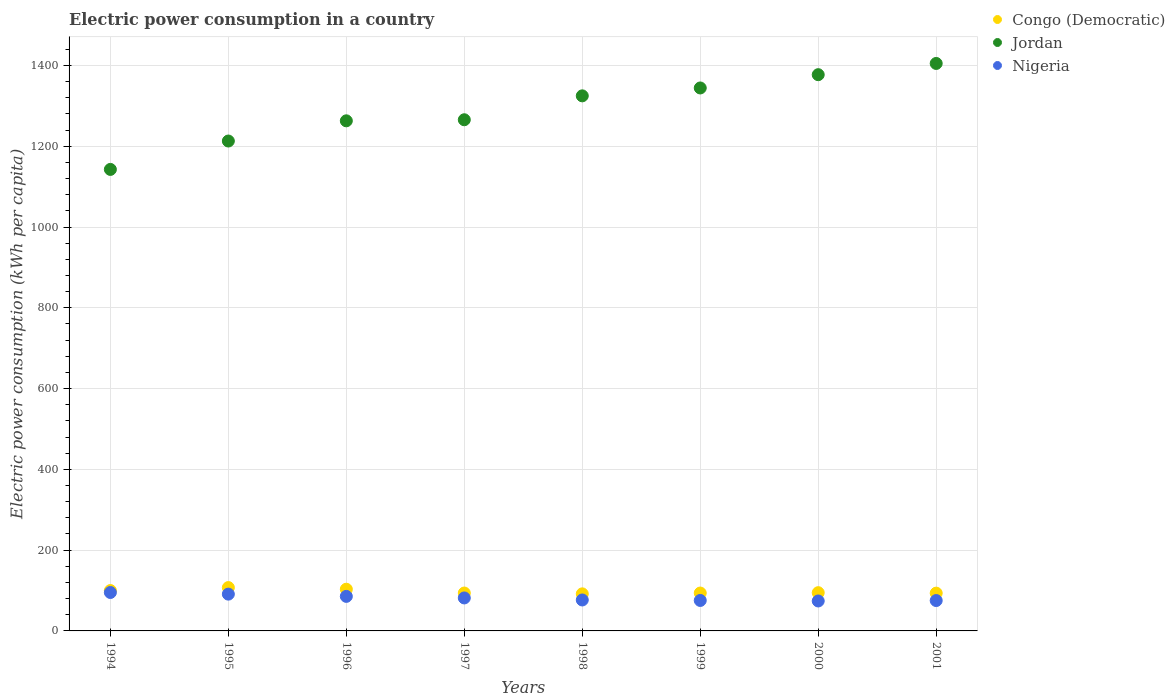How many different coloured dotlines are there?
Give a very brief answer. 3. Is the number of dotlines equal to the number of legend labels?
Provide a succinct answer. Yes. What is the electric power consumption in in Congo (Democratic) in 2001?
Your response must be concise. 93.57. Across all years, what is the maximum electric power consumption in in Nigeria?
Your answer should be very brief. 95.15. Across all years, what is the minimum electric power consumption in in Congo (Democratic)?
Your answer should be compact. 91.77. What is the total electric power consumption in in Nigeria in the graph?
Offer a terse response. 654.74. What is the difference between the electric power consumption in in Congo (Democratic) in 1997 and that in 1998?
Provide a short and direct response. 2.06. What is the difference between the electric power consumption in in Congo (Democratic) in 1998 and the electric power consumption in in Jordan in 2000?
Offer a terse response. -1285.34. What is the average electric power consumption in in Congo (Democratic) per year?
Provide a succinct answer. 97.27. In the year 1995, what is the difference between the electric power consumption in in Jordan and electric power consumption in in Nigeria?
Keep it short and to the point. 1121.79. In how many years, is the electric power consumption in in Congo (Democratic) greater than 200 kWh per capita?
Your response must be concise. 0. What is the ratio of the electric power consumption in in Congo (Democratic) in 1996 to that in 2001?
Offer a very short reply. 1.1. Is the electric power consumption in in Jordan in 1996 less than that in 1999?
Provide a short and direct response. Yes. Is the difference between the electric power consumption in in Jordan in 1997 and 1999 greater than the difference between the electric power consumption in in Nigeria in 1997 and 1999?
Your answer should be very brief. No. What is the difference between the highest and the second highest electric power consumption in in Jordan?
Provide a short and direct response. 27.81. What is the difference between the highest and the lowest electric power consumption in in Nigeria?
Give a very brief answer. 21.01. Is it the case that in every year, the sum of the electric power consumption in in Nigeria and electric power consumption in in Congo (Democratic)  is greater than the electric power consumption in in Jordan?
Make the answer very short. No. Does the electric power consumption in in Nigeria monotonically increase over the years?
Provide a short and direct response. No. Is the electric power consumption in in Jordan strictly greater than the electric power consumption in in Congo (Democratic) over the years?
Your response must be concise. Yes. Is the electric power consumption in in Congo (Democratic) strictly less than the electric power consumption in in Nigeria over the years?
Offer a terse response. No. How many years are there in the graph?
Your response must be concise. 8. Does the graph contain any zero values?
Offer a terse response. No. Where does the legend appear in the graph?
Provide a short and direct response. Top right. What is the title of the graph?
Make the answer very short. Electric power consumption in a country. Does "Myanmar" appear as one of the legend labels in the graph?
Offer a terse response. No. What is the label or title of the Y-axis?
Your response must be concise. Electric power consumption (kWh per capita). What is the Electric power consumption (kWh per capita) in Congo (Democratic) in 1994?
Offer a terse response. 99.94. What is the Electric power consumption (kWh per capita) in Jordan in 1994?
Provide a short and direct response. 1142.58. What is the Electric power consumption (kWh per capita) of Nigeria in 1994?
Offer a very short reply. 95.15. What is the Electric power consumption (kWh per capita) of Congo (Democratic) in 1995?
Give a very brief answer. 107.32. What is the Electric power consumption (kWh per capita) in Jordan in 1995?
Offer a terse response. 1212.87. What is the Electric power consumption (kWh per capita) of Nigeria in 1995?
Your response must be concise. 91.09. What is the Electric power consumption (kWh per capita) of Congo (Democratic) in 1996?
Offer a very short reply. 103.24. What is the Electric power consumption (kWh per capita) of Jordan in 1996?
Offer a terse response. 1262.89. What is the Electric power consumption (kWh per capita) of Nigeria in 1996?
Your response must be concise. 85.52. What is the Electric power consumption (kWh per capita) in Congo (Democratic) in 1997?
Provide a short and direct response. 93.83. What is the Electric power consumption (kWh per capita) in Jordan in 1997?
Provide a short and direct response. 1265.53. What is the Electric power consumption (kWh per capita) in Nigeria in 1997?
Keep it short and to the point. 81.63. What is the Electric power consumption (kWh per capita) of Congo (Democratic) in 1998?
Make the answer very short. 91.77. What is the Electric power consumption (kWh per capita) in Jordan in 1998?
Offer a very short reply. 1324.72. What is the Electric power consumption (kWh per capita) in Nigeria in 1998?
Offer a terse response. 76.61. What is the Electric power consumption (kWh per capita) of Congo (Democratic) in 1999?
Your answer should be compact. 93.78. What is the Electric power consumption (kWh per capita) in Jordan in 1999?
Provide a short and direct response. 1344.23. What is the Electric power consumption (kWh per capita) of Nigeria in 1999?
Offer a terse response. 75.41. What is the Electric power consumption (kWh per capita) in Congo (Democratic) in 2000?
Your answer should be very brief. 94.67. What is the Electric power consumption (kWh per capita) of Jordan in 2000?
Give a very brief answer. 1377.11. What is the Electric power consumption (kWh per capita) in Nigeria in 2000?
Offer a very short reply. 74.13. What is the Electric power consumption (kWh per capita) in Congo (Democratic) in 2001?
Ensure brevity in your answer.  93.57. What is the Electric power consumption (kWh per capita) of Jordan in 2001?
Keep it short and to the point. 1404.92. What is the Electric power consumption (kWh per capita) in Nigeria in 2001?
Give a very brief answer. 75.2. Across all years, what is the maximum Electric power consumption (kWh per capita) of Congo (Democratic)?
Ensure brevity in your answer.  107.32. Across all years, what is the maximum Electric power consumption (kWh per capita) in Jordan?
Give a very brief answer. 1404.92. Across all years, what is the maximum Electric power consumption (kWh per capita) of Nigeria?
Offer a terse response. 95.15. Across all years, what is the minimum Electric power consumption (kWh per capita) in Congo (Democratic)?
Provide a short and direct response. 91.77. Across all years, what is the minimum Electric power consumption (kWh per capita) of Jordan?
Your answer should be very brief. 1142.58. Across all years, what is the minimum Electric power consumption (kWh per capita) of Nigeria?
Keep it short and to the point. 74.13. What is the total Electric power consumption (kWh per capita) in Congo (Democratic) in the graph?
Offer a terse response. 778.12. What is the total Electric power consumption (kWh per capita) of Jordan in the graph?
Keep it short and to the point. 1.03e+04. What is the total Electric power consumption (kWh per capita) in Nigeria in the graph?
Your answer should be very brief. 654.74. What is the difference between the Electric power consumption (kWh per capita) of Congo (Democratic) in 1994 and that in 1995?
Give a very brief answer. -7.38. What is the difference between the Electric power consumption (kWh per capita) in Jordan in 1994 and that in 1995?
Keep it short and to the point. -70.3. What is the difference between the Electric power consumption (kWh per capita) of Nigeria in 1994 and that in 1995?
Your answer should be compact. 4.06. What is the difference between the Electric power consumption (kWh per capita) of Congo (Democratic) in 1994 and that in 1996?
Ensure brevity in your answer.  -3.29. What is the difference between the Electric power consumption (kWh per capita) in Jordan in 1994 and that in 1996?
Give a very brief answer. -120.31. What is the difference between the Electric power consumption (kWh per capita) of Nigeria in 1994 and that in 1996?
Give a very brief answer. 9.62. What is the difference between the Electric power consumption (kWh per capita) in Congo (Democratic) in 1994 and that in 1997?
Give a very brief answer. 6.11. What is the difference between the Electric power consumption (kWh per capita) of Jordan in 1994 and that in 1997?
Give a very brief answer. -122.95. What is the difference between the Electric power consumption (kWh per capita) of Nigeria in 1994 and that in 1997?
Ensure brevity in your answer.  13.51. What is the difference between the Electric power consumption (kWh per capita) of Congo (Democratic) in 1994 and that in 1998?
Make the answer very short. 8.17. What is the difference between the Electric power consumption (kWh per capita) of Jordan in 1994 and that in 1998?
Your answer should be compact. -182.14. What is the difference between the Electric power consumption (kWh per capita) of Nigeria in 1994 and that in 1998?
Provide a short and direct response. 18.53. What is the difference between the Electric power consumption (kWh per capita) of Congo (Democratic) in 1994 and that in 1999?
Give a very brief answer. 6.16. What is the difference between the Electric power consumption (kWh per capita) of Jordan in 1994 and that in 1999?
Your answer should be very brief. -201.66. What is the difference between the Electric power consumption (kWh per capita) in Nigeria in 1994 and that in 1999?
Your answer should be compact. 19.74. What is the difference between the Electric power consumption (kWh per capita) in Congo (Democratic) in 1994 and that in 2000?
Your answer should be compact. 5.27. What is the difference between the Electric power consumption (kWh per capita) in Jordan in 1994 and that in 2000?
Provide a succinct answer. -234.53. What is the difference between the Electric power consumption (kWh per capita) in Nigeria in 1994 and that in 2000?
Make the answer very short. 21.01. What is the difference between the Electric power consumption (kWh per capita) in Congo (Democratic) in 1994 and that in 2001?
Your answer should be very brief. 6.37. What is the difference between the Electric power consumption (kWh per capita) in Jordan in 1994 and that in 2001?
Provide a succinct answer. -262.35. What is the difference between the Electric power consumption (kWh per capita) in Nigeria in 1994 and that in 2001?
Provide a short and direct response. 19.95. What is the difference between the Electric power consumption (kWh per capita) of Congo (Democratic) in 1995 and that in 1996?
Ensure brevity in your answer.  4.08. What is the difference between the Electric power consumption (kWh per capita) in Jordan in 1995 and that in 1996?
Offer a very short reply. -50.02. What is the difference between the Electric power consumption (kWh per capita) in Nigeria in 1995 and that in 1996?
Offer a very short reply. 5.56. What is the difference between the Electric power consumption (kWh per capita) in Congo (Democratic) in 1995 and that in 1997?
Provide a succinct answer. 13.48. What is the difference between the Electric power consumption (kWh per capita) in Jordan in 1995 and that in 1997?
Offer a very short reply. -52.65. What is the difference between the Electric power consumption (kWh per capita) in Nigeria in 1995 and that in 1997?
Make the answer very short. 9.45. What is the difference between the Electric power consumption (kWh per capita) of Congo (Democratic) in 1995 and that in 1998?
Keep it short and to the point. 15.55. What is the difference between the Electric power consumption (kWh per capita) of Jordan in 1995 and that in 1998?
Your answer should be very brief. -111.84. What is the difference between the Electric power consumption (kWh per capita) of Nigeria in 1995 and that in 1998?
Provide a short and direct response. 14.47. What is the difference between the Electric power consumption (kWh per capita) of Congo (Democratic) in 1995 and that in 1999?
Provide a short and direct response. 13.53. What is the difference between the Electric power consumption (kWh per capita) in Jordan in 1995 and that in 1999?
Ensure brevity in your answer.  -131.36. What is the difference between the Electric power consumption (kWh per capita) in Nigeria in 1995 and that in 1999?
Keep it short and to the point. 15.68. What is the difference between the Electric power consumption (kWh per capita) in Congo (Democratic) in 1995 and that in 2000?
Make the answer very short. 12.64. What is the difference between the Electric power consumption (kWh per capita) of Jordan in 1995 and that in 2000?
Make the answer very short. -164.24. What is the difference between the Electric power consumption (kWh per capita) in Nigeria in 1995 and that in 2000?
Ensure brevity in your answer.  16.95. What is the difference between the Electric power consumption (kWh per capita) of Congo (Democratic) in 1995 and that in 2001?
Your answer should be very brief. 13.75. What is the difference between the Electric power consumption (kWh per capita) of Jordan in 1995 and that in 2001?
Provide a succinct answer. -192.05. What is the difference between the Electric power consumption (kWh per capita) in Nigeria in 1995 and that in 2001?
Offer a terse response. 15.89. What is the difference between the Electric power consumption (kWh per capita) in Congo (Democratic) in 1996 and that in 1997?
Your answer should be compact. 9.4. What is the difference between the Electric power consumption (kWh per capita) of Jordan in 1996 and that in 1997?
Make the answer very short. -2.64. What is the difference between the Electric power consumption (kWh per capita) of Nigeria in 1996 and that in 1997?
Provide a short and direct response. 3.89. What is the difference between the Electric power consumption (kWh per capita) of Congo (Democratic) in 1996 and that in 1998?
Provide a succinct answer. 11.47. What is the difference between the Electric power consumption (kWh per capita) of Jordan in 1996 and that in 1998?
Make the answer very short. -61.83. What is the difference between the Electric power consumption (kWh per capita) of Nigeria in 1996 and that in 1998?
Your answer should be compact. 8.91. What is the difference between the Electric power consumption (kWh per capita) in Congo (Democratic) in 1996 and that in 1999?
Keep it short and to the point. 9.45. What is the difference between the Electric power consumption (kWh per capita) in Jordan in 1996 and that in 1999?
Your answer should be very brief. -81.34. What is the difference between the Electric power consumption (kWh per capita) in Nigeria in 1996 and that in 1999?
Give a very brief answer. 10.11. What is the difference between the Electric power consumption (kWh per capita) in Congo (Democratic) in 1996 and that in 2000?
Your response must be concise. 8.56. What is the difference between the Electric power consumption (kWh per capita) of Jordan in 1996 and that in 2000?
Your answer should be very brief. -114.22. What is the difference between the Electric power consumption (kWh per capita) in Nigeria in 1996 and that in 2000?
Your answer should be compact. 11.39. What is the difference between the Electric power consumption (kWh per capita) in Congo (Democratic) in 1996 and that in 2001?
Provide a short and direct response. 9.66. What is the difference between the Electric power consumption (kWh per capita) in Jordan in 1996 and that in 2001?
Offer a very short reply. -142.03. What is the difference between the Electric power consumption (kWh per capita) of Nigeria in 1996 and that in 2001?
Your response must be concise. 10.32. What is the difference between the Electric power consumption (kWh per capita) in Congo (Democratic) in 1997 and that in 1998?
Make the answer very short. 2.06. What is the difference between the Electric power consumption (kWh per capita) in Jordan in 1997 and that in 1998?
Make the answer very short. -59.19. What is the difference between the Electric power consumption (kWh per capita) in Nigeria in 1997 and that in 1998?
Your answer should be very brief. 5.02. What is the difference between the Electric power consumption (kWh per capita) of Congo (Democratic) in 1997 and that in 1999?
Your answer should be very brief. 0.05. What is the difference between the Electric power consumption (kWh per capita) in Jordan in 1997 and that in 1999?
Keep it short and to the point. -78.7. What is the difference between the Electric power consumption (kWh per capita) of Nigeria in 1997 and that in 1999?
Offer a terse response. 6.22. What is the difference between the Electric power consumption (kWh per capita) of Congo (Democratic) in 1997 and that in 2000?
Provide a succinct answer. -0.84. What is the difference between the Electric power consumption (kWh per capita) in Jordan in 1997 and that in 2000?
Offer a terse response. -111.58. What is the difference between the Electric power consumption (kWh per capita) in Nigeria in 1997 and that in 2000?
Give a very brief answer. 7.5. What is the difference between the Electric power consumption (kWh per capita) of Congo (Democratic) in 1997 and that in 2001?
Provide a short and direct response. 0.26. What is the difference between the Electric power consumption (kWh per capita) of Jordan in 1997 and that in 2001?
Your answer should be compact. -139.4. What is the difference between the Electric power consumption (kWh per capita) of Nigeria in 1997 and that in 2001?
Your answer should be compact. 6.43. What is the difference between the Electric power consumption (kWh per capita) in Congo (Democratic) in 1998 and that in 1999?
Your answer should be compact. -2.02. What is the difference between the Electric power consumption (kWh per capita) in Jordan in 1998 and that in 1999?
Provide a succinct answer. -19.52. What is the difference between the Electric power consumption (kWh per capita) of Nigeria in 1998 and that in 1999?
Give a very brief answer. 1.2. What is the difference between the Electric power consumption (kWh per capita) of Congo (Democratic) in 1998 and that in 2000?
Ensure brevity in your answer.  -2.91. What is the difference between the Electric power consumption (kWh per capita) of Jordan in 1998 and that in 2000?
Make the answer very short. -52.4. What is the difference between the Electric power consumption (kWh per capita) in Nigeria in 1998 and that in 2000?
Keep it short and to the point. 2.48. What is the difference between the Electric power consumption (kWh per capita) in Congo (Democratic) in 1998 and that in 2001?
Keep it short and to the point. -1.8. What is the difference between the Electric power consumption (kWh per capita) in Jordan in 1998 and that in 2001?
Your answer should be very brief. -80.21. What is the difference between the Electric power consumption (kWh per capita) of Nigeria in 1998 and that in 2001?
Your answer should be compact. 1.42. What is the difference between the Electric power consumption (kWh per capita) of Congo (Democratic) in 1999 and that in 2000?
Offer a very short reply. -0.89. What is the difference between the Electric power consumption (kWh per capita) of Jordan in 1999 and that in 2000?
Your answer should be compact. -32.88. What is the difference between the Electric power consumption (kWh per capita) in Nigeria in 1999 and that in 2000?
Ensure brevity in your answer.  1.28. What is the difference between the Electric power consumption (kWh per capita) of Congo (Democratic) in 1999 and that in 2001?
Make the answer very short. 0.21. What is the difference between the Electric power consumption (kWh per capita) in Jordan in 1999 and that in 2001?
Make the answer very short. -60.69. What is the difference between the Electric power consumption (kWh per capita) in Nigeria in 1999 and that in 2001?
Offer a very short reply. 0.21. What is the difference between the Electric power consumption (kWh per capita) in Congo (Democratic) in 2000 and that in 2001?
Offer a terse response. 1.1. What is the difference between the Electric power consumption (kWh per capita) in Jordan in 2000 and that in 2001?
Keep it short and to the point. -27.81. What is the difference between the Electric power consumption (kWh per capita) in Nigeria in 2000 and that in 2001?
Give a very brief answer. -1.07. What is the difference between the Electric power consumption (kWh per capita) of Congo (Democratic) in 1994 and the Electric power consumption (kWh per capita) of Jordan in 1995?
Provide a succinct answer. -1112.93. What is the difference between the Electric power consumption (kWh per capita) in Congo (Democratic) in 1994 and the Electric power consumption (kWh per capita) in Nigeria in 1995?
Provide a short and direct response. 8.86. What is the difference between the Electric power consumption (kWh per capita) of Jordan in 1994 and the Electric power consumption (kWh per capita) of Nigeria in 1995?
Your response must be concise. 1051.49. What is the difference between the Electric power consumption (kWh per capita) in Congo (Democratic) in 1994 and the Electric power consumption (kWh per capita) in Jordan in 1996?
Your response must be concise. -1162.95. What is the difference between the Electric power consumption (kWh per capita) in Congo (Democratic) in 1994 and the Electric power consumption (kWh per capita) in Nigeria in 1996?
Your response must be concise. 14.42. What is the difference between the Electric power consumption (kWh per capita) of Jordan in 1994 and the Electric power consumption (kWh per capita) of Nigeria in 1996?
Your answer should be very brief. 1057.05. What is the difference between the Electric power consumption (kWh per capita) in Congo (Democratic) in 1994 and the Electric power consumption (kWh per capita) in Jordan in 1997?
Give a very brief answer. -1165.59. What is the difference between the Electric power consumption (kWh per capita) of Congo (Democratic) in 1994 and the Electric power consumption (kWh per capita) of Nigeria in 1997?
Your response must be concise. 18.31. What is the difference between the Electric power consumption (kWh per capita) in Jordan in 1994 and the Electric power consumption (kWh per capita) in Nigeria in 1997?
Your answer should be compact. 1060.94. What is the difference between the Electric power consumption (kWh per capita) in Congo (Democratic) in 1994 and the Electric power consumption (kWh per capita) in Jordan in 1998?
Offer a terse response. -1224.77. What is the difference between the Electric power consumption (kWh per capita) in Congo (Democratic) in 1994 and the Electric power consumption (kWh per capita) in Nigeria in 1998?
Ensure brevity in your answer.  23.33. What is the difference between the Electric power consumption (kWh per capita) in Jordan in 1994 and the Electric power consumption (kWh per capita) in Nigeria in 1998?
Your answer should be very brief. 1065.96. What is the difference between the Electric power consumption (kWh per capita) of Congo (Democratic) in 1994 and the Electric power consumption (kWh per capita) of Jordan in 1999?
Your answer should be very brief. -1244.29. What is the difference between the Electric power consumption (kWh per capita) of Congo (Democratic) in 1994 and the Electric power consumption (kWh per capita) of Nigeria in 1999?
Offer a very short reply. 24.53. What is the difference between the Electric power consumption (kWh per capita) in Jordan in 1994 and the Electric power consumption (kWh per capita) in Nigeria in 1999?
Ensure brevity in your answer.  1067.17. What is the difference between the Electric power consumption (kWh per capita) in Congo (Democratic) in 1994 and the Electric power consumption (kWh per capita) in Jordan in 2000?
Offer a very short reply. -1277.17. What is the difference between the Electric power consumption (kWh per capita) in Congo (Democratic) in 1994 and the Electric power consumption (kWh per capita) in Nigeria in 2000?
Provide a succinct answer. 25.81. What is the difference between the Electric power consumption (kWh per capita) in Jordan in 1994 and the Electric power consumption (kWh per capita) in Nigeria in 2000?
Offer a terse response. 1068.44. What is the difference between the Electric power consumption (kWh per capita) in Congo (Democratic) in 1994 and the Electric power consumption (kWh per capita) in Jordan in 2001?
Offer a terse response. -1304.98. What is the difference between the Electric power consumption (kWh per capita) in Congo (Democratic) in 1994 and the Electric power consumption (kWh per capita) in Nigeria in 2001?
Your response must be concise. 24.74. What is the difference between the Electric power consumption (kWh per capita) in Jordan in 1994 and the Electric power consumption (kWh per capita) in Nigeria in 2001?
Provide a short and direct response. 1067.38. What is the difference between the Electric power consumption (kWh per capita) of Congo (Democratic) in 1995 and the Electric power consumption (kWh per capita) of Jordan in 1996?
Make the answer very short. -1155.57. What is the difference between the Electric power consumption (kWh per capita) of Congo (Democratic) in 1995 and the Electric power consumption (kWh per capita) of Nigeria in 1996?
Provide a succinct answer. 21.79. What is the difference between the Electric power consumption (kWh per capita) in Jordan in 1995 and the Electric power consumption (kWh per capita) in Nigeria in 1996?
Your answer should be compact. 1127.35. What is the difference between the Electric power consumption (kWh per capita) in Congo (Democratic) in 1995 and the Electric power consumption (kWh per capita) in Jordan in 1997?
Keep it short and to the point. -1158.21. What is the difference between the Electric power consumption (kWh per capita) in Congo (Democratic) in 1995 and the Electric power consumption (kWh per capita) in Nigeria in 1997?
Offer a very short reply. 25.68. What is the difference between the Electric power consumption (kWh per capita) of Jordan in 1995 and the Electric power consumption (kWh per capita) of Nigeria in 1997?
Make the answer very short. 1131.24. What is the difference between the Electric power consumption (kWh per capita) in Congo (Democratic) in 1995 and the Electric power consumption (kWh per capita) in Jordan in 1998?
Offer a very short reply. -1217.4. What is the difference between the Electric power consumption (kWh per capita) of Congo (Democratic) in 1995 and the Electric power consumption (kWh per capita) of Nigeria in 1998?
Ensure brevity in your answer.  30.7. What is the difference between the Electric power consumption (kWh per capita) in Jordan in 1995 and the Electric power consumption (kWh per capita) in Nigeria in 1998?
Provide a succinct answer. 1136.26. What is the difference between the Electric power consumption (kWh per capita) of Congo (Democratic) in 1995 and the Electric power consumption (kWh per capita) of Jordan in 1999?
Provide a short and direct response. -1236.91. What is the difference between the Electric power consumption (kWh per capita) of Congo (Democratic) in 1995 and the Electric power consumption (kWh per capita) of Nigeria in 1999?
Offer a terse response. 31.91. What is the difference between the Electric power consumption (kWh per capita) in Jordan in 1995 and the Electric power consumption (kWh per capita) in Nigeria in 1999?
Your answer should be very brief. 1137.46. What is the difference between the Electric power consumption (kWh per capita) in Congo (Democratic) in 1995 and the Electric power consumption (kWh per capita) in Jordan in 2000?
Keep it short and to the point. -1269.79. What is the difference between the Electric power consumption (kWh per capita) in Congo (Democratic) in 1995 and the Electric power consumption (kWh per capita) in Nigeria in 2000?
Your answer should be compact. 33.19. What is the difference between the Electric power consumption (kWh per capita) of Jordan in 1995 and the Electric power consumption (kWh per capita) of Nigeria in 2000?
Ensure brevity in your answer.  1138.74. What is the difference between the Electric power consumption (kWh per capita) of Congo (Democratic) in 1995 and the Electric power consumption (kWh per capita) of Jordan in 2001?
Offer a very short reply. -1297.61. What is the difference between the Electric power consumption (kWh per capita) in Congo (Democratic) in 1995 and the Electric power consumption (kWh per capita) in Nigeria in 2001?
Your answer should be compact. 32.12. What is the difference between the Electric power consumption (kWh per capita) of Jordan in 1995 and the Electric power consumption (kWh per capita) of Nigeria in 2001?
Give a very brief answer. 1137.67. What is the difference between the Electric power consumption (kWh per capita) of Congo (Democratic) in 1996 and the Electric power consumption (kWh per capita) of Jordan in 1997?
Provide a succinct answer. -1162.29. What is the difference between the Electric power consumption (kWh per capita) of Congo (Democratic) in 1996 and the Electric power consumption (kWh per capita) of Nigeria in 1997?
Provide a succinct answer. 21.6. What is the difference between the Electric power consumption (kWh per capita) of Jordan in 1996 and the Electric power consumption (kWh per capita) of Nigeria in 1997?
Offer a terse response. 1181.26. What is the difference between the Electric power consumption (kWh per capita) in Congo (Democratic) in 1996 and the Electric power consumption (kWh per capita) in Jordan in 1998?
Provide a succinct answer. -1221.48. What is the difference between the Electric power consumption (kWh per capita) in Congo (Democratic) in 1996 and the Electric power consumption (kWh per capita) in Nigeria in 1998?
Give a very brief answer. 26.62. What is the difference between the Electric power consumption (kWh per capita) of Jordan in 1996 and the Electric power consumption (kWh per capita) of Nigeria in 1998?
Offer a very short reply. 1186.28. What is the difference between the Electric power consumption (kWh per capita) of Congo (Democratic) in 1996 and the Electric power consumption (kWh per capita) of Jordan in 1999?
Your answer should be compact. -1241. What is the difference between the Electric power consumption (kWh per capita) of Congo (Democratic) in 1996 and the Electric power consumption (kWh per capita) of Nigeria in 1999?
Your answer should be compact. 27.83. What is the difference between the Electric power consumption (kWh per capita) of Jordan in 1996 and the Electric power consumption (kWh per capita) of Nigeria in 1999?
Provide a short and direct response. 1187.48. What is the difference between the Electric power consumption (kWh per capita) in Congo (Democratic) in 1996 and the Electric power consumption (kWh per capita) in Jordan in 2000?
Provide a succinct answer. -1273.88. What is the difference between the Electric power consumption (kWh per capita) of Congo (Democratic) in 1996 and the Electric power consumption (kWh per capita) of Nigeria in 2000?
Provide a short and direct response. 29.1. What is the difference between the Electric power consumption (kWh per capita) of Jordan in 1996 and the Electric power consumption (kWh per capita) of Nigeria in 2000?
Provide a short and direct response. 1188.76. What is the difference between the Electric power consumption (kWh per capita) of Congo (Democratic) in 1996 and the Electric power consumption (kWh per capita) of Jordan in 2001?
Provide a short and direct response. -1301.69. What is the difference between the Electric power consumption (kWh per capita) in Congo (Democratic) in 1996 and the Electric power consumption (kWh per capita) in Nigeria in 2001?
Your answer should be compact. 28.04. What is the difference between the Electric power consumption (kWh per capita) in Jordan in 1996 and the Electric power consumption (kWh per capita) in Nigeria in 2001?
Your answer should be compact. 1187.69. What is the difference between the Electric power consumption (kWh per capita) of Congo (Democratic) in 1997 and the Electric power consumption (kWh per capita) of Jordan in 1998?
Provide a succinct answer. -1230.88. What is the difference between the Electric power consumption (kWh per capita) in Congo (Democratic) in 1997 and the Electric power consumption (kWh per capita) in Nigeria in 1998?
Ensure brevity in your answer.  17.22. What is the difference between the Electric power consumption (kWh per capita) of Jordan in 1997 and the Electric power consumption (kWh per capita) of Nigeria in 1998?
Offer a very short reply. 1188.91. What is the difference between the Electric power consumption (kWh per capita) of Congo (Democratic) in 1997 and the Electric power consumption (kWh per capita) of Jordan in 1999?
Offer a very short reply. -1250.4. What is the difference between the Electric power consumption (kWh per capita) in Congo (Democratic) in 1997 and the Electric power consumption (kWh per capita) in Nigeria in 1999?
Your response must be concise. 18.42. What is the difference between the Electric power consumption (kWh per capita) in Jordan in 1997 and the Electric power consumption (kWh per capita) in Nigeria in 1999?
Give a very brief answer. 1190.12. What is the difference between the Electric power consumption (kWh per capita) in Congo (Democratic) in 1997 and the Electric power consumption (kWh per capita) in Jordan in 2000?
Keep it short and to the point. -1283.28. What is the difference between the Electric power consumption (kWh per capita) in Congo (Democratic) in 1997 and the Electric power consumption (kWh per capita) in Nigeria in 2000?
Give a very brief answer. 19.7. What is the difference between the Electric power consumption (kWh per capita) of Jordan in 1997 and the Electric power consumption (kWh per capita) of Nigeria in 2000?
Your response must be concise. 1191.4. What is the difference between the Electric power consumption (kWh per capita) of Congo (Democratic) in 1997 and the Electric power consumption (kWh per capita) of Jordan in 2001?
Offer a very short reply. -1311.09. What is the difference between the Electric power consumption (kWh per capita) in Congo (Democratic) in 1997 and the Electric power consumption (kWh per capita) in Nigeria in 2001?
Ensure brevity in your answer.  18.63. What is the difference between the Electric power consumption (kWh per capita) in Jordan in 1997 and the Electric power consumption (kWh per capita) in Nigeria in 2001?
Your answer should be very brief. 1190.33. What is the difference between the Electric power consumption (kWh per capita) in Congo (Democratic) in 1998 and the Electric power consumption (kWh per capita) in Jordan in 1999?
Ensure brevity in your answer.  -1252.46. What is the difference between the Electric power consumption (kWh per capita) in Congo (Democratic) in 1998 and the Electric power consumption (kWh per capita) in Nigeria in 1999?
Provide a short and direct response. 16.36. What is the difference between the Electric power consumption (kWh per capita) in Jordan in 1998 and the Electric power consumption (kWh per capita) in Nigeria in 1999?
Make the answer very short. 1249.31. What is the difference between the Electric power consumption (kWh per capita) of Congo (Democratic) in 1998 and the Electric power consumption (kWh per capita) of Jordan in 2000?
Your answer should be very brief. -1285.34. What is the difference between the Electric power consumption (kWh per capita) of Congo (Democratic) in 1998 and the Electric power consumption (kWh per capita) of Nigeria in 2000?
Provide a short and direct response. 17.64. What is the difference between the Electric power consumption (kWh per capita) in Jordan in 1998 and the Electric power consumption (kWh per capita) in Nigeria in 2000?
Ensure brevity in your answer.  1250.58. What is the difference between the Electric power consumption (kWh per capita) of Congo (Democratic) in 1998 and the Electric power consumption (kWh per capita) of Jordan in 2001?
Your answer should be compact. -1313.15. What is the difference between the Electric power consumption (kWh per capita) in Congo (Democratic) in 1998 and the Electric power consumption (kWh per capita) in Nigeria in 2001?
Offer a very short reply. 16.57. What is the difference between the Electric power consumption (kWh per capita) in Jordan in 1998 and the Electric power consumption (kWh per capita) in Nigeria in 2001?
Offer a very short reply. 1249.52. What is the difference between the Electric power consumption (kWh per capita) in Congo (Democratic) in 1999 and the Electric power consumption (kWh per capita) in Jordan in 2000?
Ensure brevity in your answer.  -1283.33. What is the difference between the Electric power consumption (kWh per capita) of Congo (Democratic) in 1999 and the Electric power consumption (kWh per capita) of Nigeria in 2000?
Your answer should be compact. 19.65. What is the difference between the Electric power consumption (kWh per capita) in Jordan in 1999 and the Electric power consumption (kWh per capita) in Nigeria in 2000?
Keep it short and to the point. 1270.1. What is the difference between the Electric power consumption (kWh per capita) in Congo (Democratic) in 1999 and the Electric power consumption (kWh per capita) in Jordan in 2001?
Ensure brevity in your answer.  -1311.14. What is the difference between the Electric power consumption (kWh per capita) in Congo (Democratic) in 1999 and the Electric power consumption (kWh per capita) in Nigeria in 2001?
Make the answer very short. 18.59. What is the difference between the Electric power consumption (kWh per capita) of Jordan in 1999 and the Electric power consumption (kWh per capita) of Nigeria in 2001?
Keep it short and to the point. 1269.03. What is the difference between the Electric power consumption (kWh per capita) in Congo (Democratic) in 2000 and the Electric power consumption (kWh per capita) in Jordan in 2001?
Your answer should be very brief. -1310.25. What is the difference between the Electric power consumption (kWh per capita) in Congo (Democratic) in 2000 and the Electric power consumption (kWh per capita) in Nigeria in 2001?
Keep it short and to the point. 19.48. What is the difference between the Electric power consumption (kWh per capita) of Jordan in 2000 and the Electric power consumption (kWh per capita) of Nigeria in 2001?
Your answer should be compact. 1301.91. What is the average Electric power consumption (kWh per capita) in Congo (Democratic) per year?
Provide a succinct answer. 97.27. What is the average Electric power consumption (kWh per capita) of Jordan per year?
Keep it short and to the point. 1291.86. What is the average Electric power consumption (kWh per capita) in Nigeria per year?
Make the answer very short. 81.84. In the year 1994, what is the difference between the Electric power consumption (kWh per capita) of Congo (Democratic) and Electric power consumption (kWh per capita) of Jordan?
Your answer should be very brief. -1042.63. In the year 1994, what is the difference between the Electric power consumption (kWh per capita) of Congo (Democratic) and Electric power consumption (kWh per capita) of Nigeria?
Offer a terse response. 4.79. In the year 1994, what is the difference between the Electric power consumption (kWh per capita) in Jordan and Electric power consumption (kWh per capita) in Nigeria?
Make the answer very short. 1047.43. In the year 1995, what is the difference between the Electric power consumption (kWh per capita) of Congo (Democratic) and Electric power consumption (kWh per capita) of Jordan?
Your answer should be compact. -1105.56. In the year 1995, what is the difference between the Electric power consumption (kWh per capita) in Congo (Democratic) and Electric power consumption (kWh per capita) in Nigeria?
Your response must be concise. 16.23. In the year 1995, what is the difference between the Electric power consumption (kWh per capita) in Jordan and Electric power consumption (kWh per capita) in Nigeria?
Keep it short and to the point. 1121.79. In the year 1996, what is the difference between the Electric power consumption (kWh per capita) of Congo (Democratic) and Electric power consumption (kWh per capita) of Jordan?
Offer a very short reply. -1159.65. In the year 1996, what is the difference between the Electric power consumption (kWh per capita) of Congo (Democratic) and Electric power consumption (kWh per capita) of Nigeria?
Make the answer very short. 17.71. In the year 1996, what is the difference between the Electric power consumption (kWh per capita) of Jordan and Electric power consumption (kWh per capita) of Nigeria?
Provide a short and direct response. 1177.37. In the year 1997, what is the difference between the Electric power consumption (kWh per capita) of Congo (Democratic) and Electric power consumption (kWh per capita) of Jordan?
Provide a short and direct response. -1171.69. In the year 1997, what is the difference between the Electric power consumption (kWh per capita) of Congo (Democratic) and Electric power consumption (kWh per capita) of Nigeria?
Give a very brief answer. 12.2. In the year 1997, what is the difference between the Electric power consumption (kWh per capita) in Jordan and Electric power consumption (kWh per capita) in Nigeria?
Give a very brief answer. 1183.89. In the year 1998, what is the difference between the Electric power consumption (kWh per capita) in Congo (Democratic) and Electric power consumption (kWh per capita) in Jordan?
Offer a terse response. -1232.95. In the year 1998, what is the difference between the Electric power consumption (kWh per capita) in Congo (Democratic) and Electric power consumption (kWh per capita) in Nigeria?
Give a very brief answer. 15.15. In the year 1998, what is the difference between the Electric power consumption (kWh per capita) of Jordan and Electric power consumption (kWh per capita) of Nigeria?
Provide a succinct answer. 1248.1. In the year 1999, what is the difference between the Electric power consumption (kWh per capita) in Congo (Democratic) and Electric power consumption (kWh per capita) in Jordan?
Offer a terse response. -1250.45. In the year 1999, what is the difference between the Electric power consumption (kWh per capita) in Congo (Democratic) and Electric power consumption (kWh per capita) in Nigeria?
Keep it short and to the point. 18.38. In the year 1999, what is the difference between the Electric power consumption (kWh per capita) in Jordan and Electric power consumption (kWh per capita) in Nigeria?
Ensure brevity in your answer.  1268.82. In the year 2000, what is the difference between the Electric power consumption (kWh per capita) in Congo (Democratic) and Electric power consumption (kWh per capita) in Jordan?
Keep it short and to the point. -1282.44. In the year 2000, what is the difference between the Electric power consumption (kWh per capita) of Congo (Democratic) and Electric power consumption (kWh per capita) of Nigeria?
Give a very brief answer. 20.54. In the year 2000, what is the difference between the Electric power consumption (kWh per capita) of Jordan and Electric power consumption (kWh per capita) of Nigeria?
Offer a terse response. 1302.98. In the year 2001, what is the difference between the Electric power consumption (kWh per capita) in Congo (Democratic) and Electric power consumption (kWh per capita) in Jordan?
Make the answer very short. -1311.35. In the year 2001, what is the difference between the Electric power consumption (kWh per capita) of Congo (Democratic) and Electric power consumption (kWh per capita) of Nigeria?
Your answer should be very brief. 18.37. In the year 2001, what is the difference between the Electric power consumption (kWh per capita) of Jordan and Electric power consumption (kWh per capita) of Nigeria?
Give a very brief answer. 1329.72. What is the ratio of the Electric power consumption (kWh per capita) of Congo (Democratic) in 1994 to that in 1995?
Provide a short and direct response. 0.93. What is the ratio of the Electric power consumption (kWh per capita) in Jordan in 1994 to that in 1995?
Give a very brief answer. 0.94. What is the ratio of the Electric power consumption (kWh per capita) in Nigeria in 1994 to that in 1995?
Your response must be concise. 1.04. What is the ratio of the Electric power consumption (kWh per capita) in Congo (Democratic) in 1994 to that in 1996?
Offer a very short reply. 0.97. What is the ratio of the Electric power consumption (kWh per capita) of Jordan in 1994 to that in 1996?
Your answer should be very brief. 0.9. What is the ratio of the Electric power consumption (kWh per capita) of Nigeria in 1994 to that in 1996?
Offer a very short reply. 1.11. What is the ratio of the Electric power consumption (kWh per capita) of Congo (Democratic) in 1994 to that in 1997?
Ensure brevity in your answer.  1.07. What is the ratio of the Electric power consumption (kWh per capita) in Jordan in 1994 to that in 1997?
Your answer should be compact. 0.9. What is the ratio of the Electric power consumption (kWh per capita) of Nigeria in 1994 to that in 1997?
Your answer should be compact. 1.17. What is the ratio of the Electric power consumption (kWh per capita) of Congo (Democratic) in 1994 to that in 1998?
Keep it short and to the point. 1.09. What is the ratio of the Electric power consumption (kWh per capita) of Jordan in 1994 to that in 1998?
Your answer should be compact. 0.86. What is the ratio of the Electric power consumption (kWh per capita) in Nigeria in 1994 to that in 1998?
Your answer should be very brief. 1.24. What is the ratio of the Electric power consumption (kWh per capita) in Congo (Democratic) in 1994 to that in 1999?
Offer a very short reply. 1.07. What is the ratio of the Electric power consumption (kWh per capita) of Nigeria in 1994 to that in 1999?
Provide a short and direct response. 1.26. What is the ratio of the Electric power consumption (kWh per capita) of Congo (Democratic) in 1994 to that in 2000?
Provide a succinct answer. 1.06. What is the ratio of the Electric power consumption (kWh per capita) of Jordan in 1994 to that in 2000?
Your answer should be compact. 0.83. What is the ratio of the Electric power consumption (kWh per capita) in Nigeria in 1994 to that in 2000?
Keep it short and to the point. 1.28. What is the ratio of the Electric power consumption (kWh per capita) in Congo (Democratic) in 1994 to that in 2001?
Provide a short and direct response. 1.07. What is the ratio of the Electric power consumption (kWh per capita) of Jordan in 1994 to that in 2001?
Make the answer very short. 0.81. What is the ratio of the Electric power consumption (kWh per capita) of Nigeria in 1994 to that in 2001?
Keep it short and to the point. 1.27. What is the ratio of the Electric power consumption (kWh per capita) of Congo (Democratic) in 1995 to that in 1996?
Your answer should be compact. 1.04. What is the ratio of the Electric power consumption (kWh per capita) in Jordan in 1995 to that in 1996?
Make the answer very short. 0.96. What is the ratio of the Electric power consumption (kWh per capita) of Nigeria in 1995 to that in 1996?
Ensure brevity in your answer.  1.07. What is the ratio of the Electric power consumption (kWh per capita) in Congo (Democratic) in 1995 to that in 1997?
Make the answer very short. 1.14. What is the ratio of the Electric power consumption (kWh per capita) in Jordan in 1995 to that in 1997?
Provide a succinct answer. 0.96. What is the ratio of the Electric power consumption (kWh per capita) in Nigeria in 1995 to that in 1997?
Provide a short and direct response. 1.12. What is the ratio of the Electric power consumption (kWh per capita) in Congo (Democratic) in 1995 to that in 1998?
Give a very brief answer. 1.17. What is the ratio of the Electric power consumption (kWh per capita) in Jordan in 1995 to that in 1998?
Give a very brief answer. 0.92. What is the ratio of the Electric power consumption (kWh per capita) of Nigeria in 1995 to that in 1998?
Offer a terse response. 1.19. What is the ratio of the Electric power consumption (kWh per capita) in Congo (Democratic) in 1995 to that in 1999?
Your response must be concise. 1.14. What is the ratio of the Electric power consumption (kWh per capita) in Jordan in 1995 to that in 1999?
Your answer should be compact. 0.9. What is the ratio of the Electric power consumption (kWh per capita) in Nigeria in 1995 to that in 1999?
Your answer should be very brief. 1.21. What is the ratio of the Electric power consumption (kWh per capita) of Congo (Democratic) in 1995 to that in 2000?
Give a very brief answer. 1.13. What is the ratio of the Electric power consumption (kWh per capita) of Jordan in 1995 to that in 2000?
Give a very brief answer. 0.88. What is the ratio of the Electric power consumption (kWh per capita) in Nigeria in 1995 to that in 2000?
Provide a short and direct response. 1.23. What is the ratio of the Electric power consumption (kWh per capita) of Congo (Democratic) in 1995 to that in 2001?
Offer a terse response. 1.15. What is the ratio of the Electric power consumption (kWh per capita) in Jordan in 1995 to that in 2001?
Your answer should be compact. 0.86. What is the ratio of the Electric power consumption (kWh per capita) of Nigeria in 1995 to that in 2001?
Make the answer very short. 1.21. What is the ratio of the Electric power consumption (kWh per capita) of Congo (Democratic) in 1996 to that in 1997?
Ensure brevity in your answer.  1.1. What is the ratio of the Electric power consumption (kWh per capita) of Nigeria in 1996 to that in 1997?
Offer a terse response. 1.05. What is the ratio of the Electric power consumption (kWh per capita) in Congo (Democratic) in 1996 to that in 1998?
Provide a succinct answer. 1.12. What is the ratio of the Electric power consumption (kWh per capita) in Jordan in 1996 to that in 1998?
Make the answer very short. 0.95. What is the ratio of the Electric power consumption (kWh per capita) in Nigeria in 1996 to that in 1998?
Keep it short and to the point. 1.12. What is the ratio of the Electric power consumption (kWh per capita) in Congo (Democratic) in 1996 to that in 1999?
Your answer should be compact. 1.1. What is the ratio of the Electric power consumption (kWh per capita) in Jordan in 1996 to that in 1999?
Provide a short and direct response. 0.94. What is the ratio of the Electric power consumption (kWh per capita) of Nigeria in 1996 to that in 1999?
Your response must be concise. 1.13. What is the ratio of the Electric power consumption (kWh per capita) of Congo (Democratic) in 1996 to that in 2000?
Keep it short and to the point. 1.09. What is the ratio of the Electric power consumption (kWh per capita) of Jordan in 1996 to that in 2000?
Your answer should be very brief. 0.92. What is the ratio of the Electric power consumption (kWh per capita) in Nigeria in 1996 to that in 2000?
Offer a very short reply. 1.15. What is the ratio of the Electric power consumption (kWh per capita) of Congo (Democratic) in 1996 to that in 2001?
Ensure brevity in your answer.  1.1. What is the ratio of the Electric power consumption (kWh per capita) of Jordan in 1996 to that in 2001?
Ensure brevity in your answer.  0.9. What is the ratio of the Electric power consumption (kWh per capita) in Nigeria in 1996 to that in 2001?
Provide a succinct answer. 1.14. What is the ratio of the Electric power consumption (kWh per capita) of Congo (Democratic) in 1997 to that in 1998?
Ensure brevity in your answer.  1.02. What is the ratio of the Electric power consumption (kWh per capita) of Jordan in 1997 to that in 1998?
Your answer should be compact. 0.96. What is the ratio of the Electric power consumption (kWh per capita) in Nigeria in 1997 to that in 1998?
Make the answer very short. 1.07. What is the ratio of the Electric power consumption (kWh per capita) of Congo (Democratic) in 1997 to that in 1999?
Keep it short and to the point. 1. What is the ratio of the Electric power consumption (kWh per capita) in Jordan in 1997 to that in 1999?
Your response must be concise. 0.94. What is the ratio of the Electric power consumption (kWh per capita) of Nigeria in 1997 to that in 1999?
Offer a terse response. 1.08. What is the ratio of the Electric power consumption (kWh per capita) in Congo (Democratic) in 1997 to that in 2000?
Keep it short and to the point. 0.99. What is the ratio of the Electric power consumption (kWh per capita) in Jordan in 1997 to that in 2000?
Keep it short and to the point. 0.92. What is the ratio of the Electric power consumption (kWh per capita) of Nigeria in 1997 to that in 2000?
Offer a terse response. 1.1. What is the ratio of the Electric power consumption (kWh per capita) in Jordan in 1997 to that in 2001?
Give a very brief answer. 0.9. What is the ratio of the Electric power consumption (kWh per capita) of Nigeria in 1997 to that in 2001?
Offer a terse response. 1.09. What is the ratio of the Electric power consumption (kWh per capita) in Congo (Democratic) in 1998 to that in 1999?
Give a very brief answer. 0.98. What is the ratio of the Electric power consumption (kWh per capita) of Jordan in 1998 to that in 1999?
Keep it short and to the point. 0.99. What is the ratio of the Electric power consumption (kWh per capita) in Congo (Democratic) in 1998 to that in 2000?
Your answer should be very brief. 0.97. What is the ratio of the Electric power consumption (kWh per capita) of Jordan in 1998 to that in 2000?
Keep it short and to the point. 0.96. What is the ratio of the Electric power consumption (kWh per capita) of Nigeria in 1998 to that in 2000?
Provide a succinct answer. 1.03. What is the ratio of the Electric power consumption (kWh per capita) of Congo (Democratic) in 1998 to that in 2001?
Your answer should be very brief. 0.98. What is the ratio of the Electric power consumption (kWh per capita) in Jordan in 1998 to that in 2001?
Your response must be concise. 0.94. What is the ratio of the Electric power consumption (kWh per capita) of Nigeria in 1998 to that in 2001?
Your answer should be compact. 1.02. What is the ratio of the Electric power consumption (kWh per capita) of Congo (Democratic) in 1999 to that in 2000?
Give a very brief answer. 0.99. What is the ratio of the Electric power consumption (kWh per capita) of Jordan in 1999 to that in 2000?
Keep it short and to the point. 0.98. What is the ratio of the Electric power consumption (kWh per capita) in Nigeria in 1999 to that in 2000?
Keep it short and to the point. 1.02. What is the ratio of the Electric power consumption (kWh per capita) of Jordan in 1999 to that in 2001?
Provide a short and direct response. 0.96. What is the ratio of the Electric power consumption (kWh per capita) of Congo (Democratic) in 2000 to that in 2001?
Provide a short and direct response. 1.01. What is the ratio of the Electric power consumption (kWh per capita) in Jordan in 2000 to that in 2001?
Keep it short and to the point. 0.98. What is the ratio of the Electric power consumption (kWh per capita) of Nigeria in 2000 to that in 2001?
Give a very brief answer. 0.99. What is the difference between the highest and the second highest Electric power consumption (kWh per capita) in Congo (Democratic)?
Your response must be concise. 4.08. What is the difference between the highest and the second highest Electric power consumption (kWh per capita) in Jordan?
Ensure brevity in your answer.  27.81. What is the difference between the highest and the second highest Electric power consumption (kWh per capita) in Nigeria?
Make the answer very short. 4.06. What is the difference between the highest and the lowest Electric power consumption (kWh per capita) of Congo (Democratic)?
Offer a very short reply. 15.55. What is the difference between the highest and the lowest Electric power consumption (kWh per capita) of Jordan?
Your answer should be very brief. 262.35. What is the difference between the highest and the lowest Electric power consumption (kWh per capita) in Nigeria?
Make the answer very short. 21.01. 